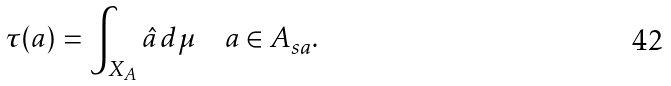Convert formula to latex. <formula><loc_0><loc_0><loc_500><loc_500>\tau ( a ) = \int _ { X _ { A } } \hat { a } \, d \mu \quad a \in A _ { s a } .</formula> 